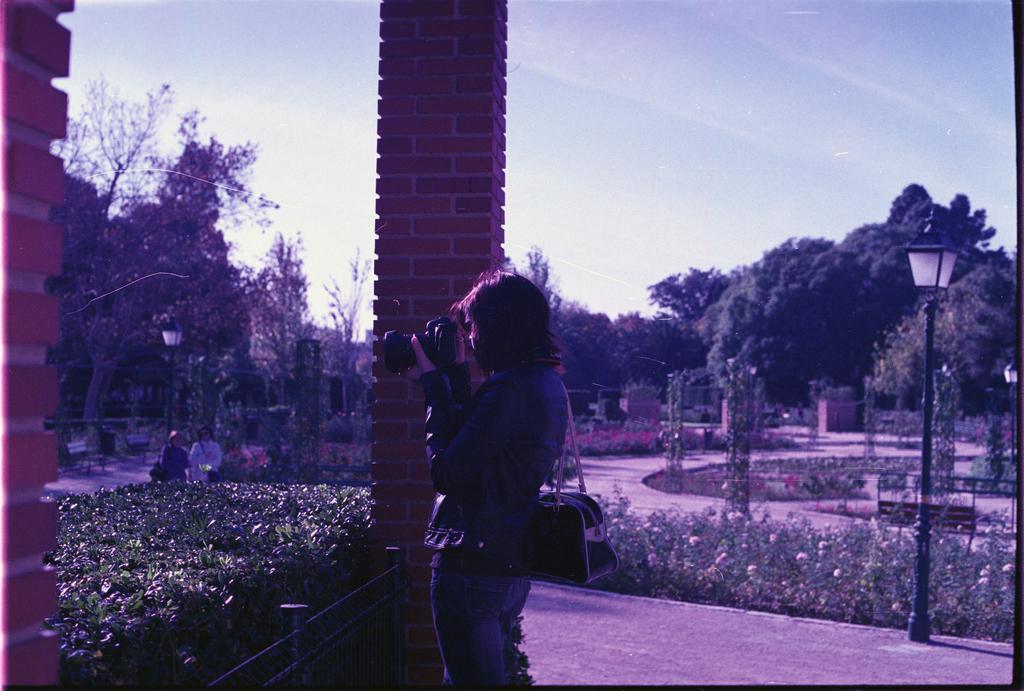Can you describe this image briefly? In this picture I can see a woman holding camera, around I can see few people, plants, trees and pillories. 